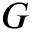Convert formula to latex. <formula><loc_0><loc_0><loc_500><loc_500>G</formula> 